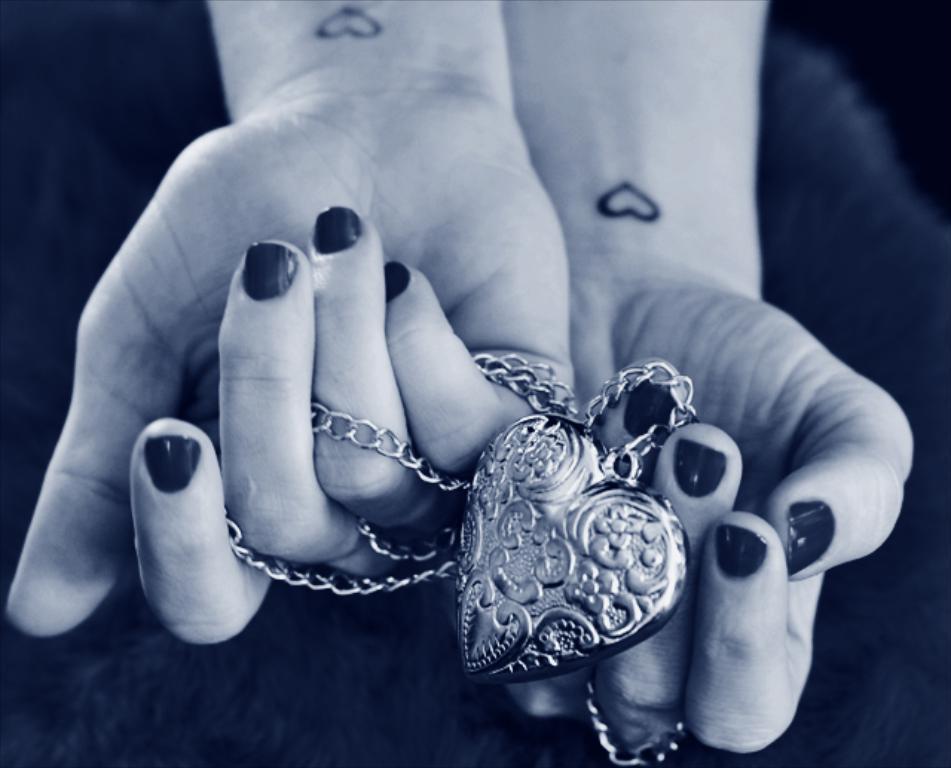In one or two sentences, can you explain what this image depicts? In this image we can see the person's hand holding keychain and dark background. 